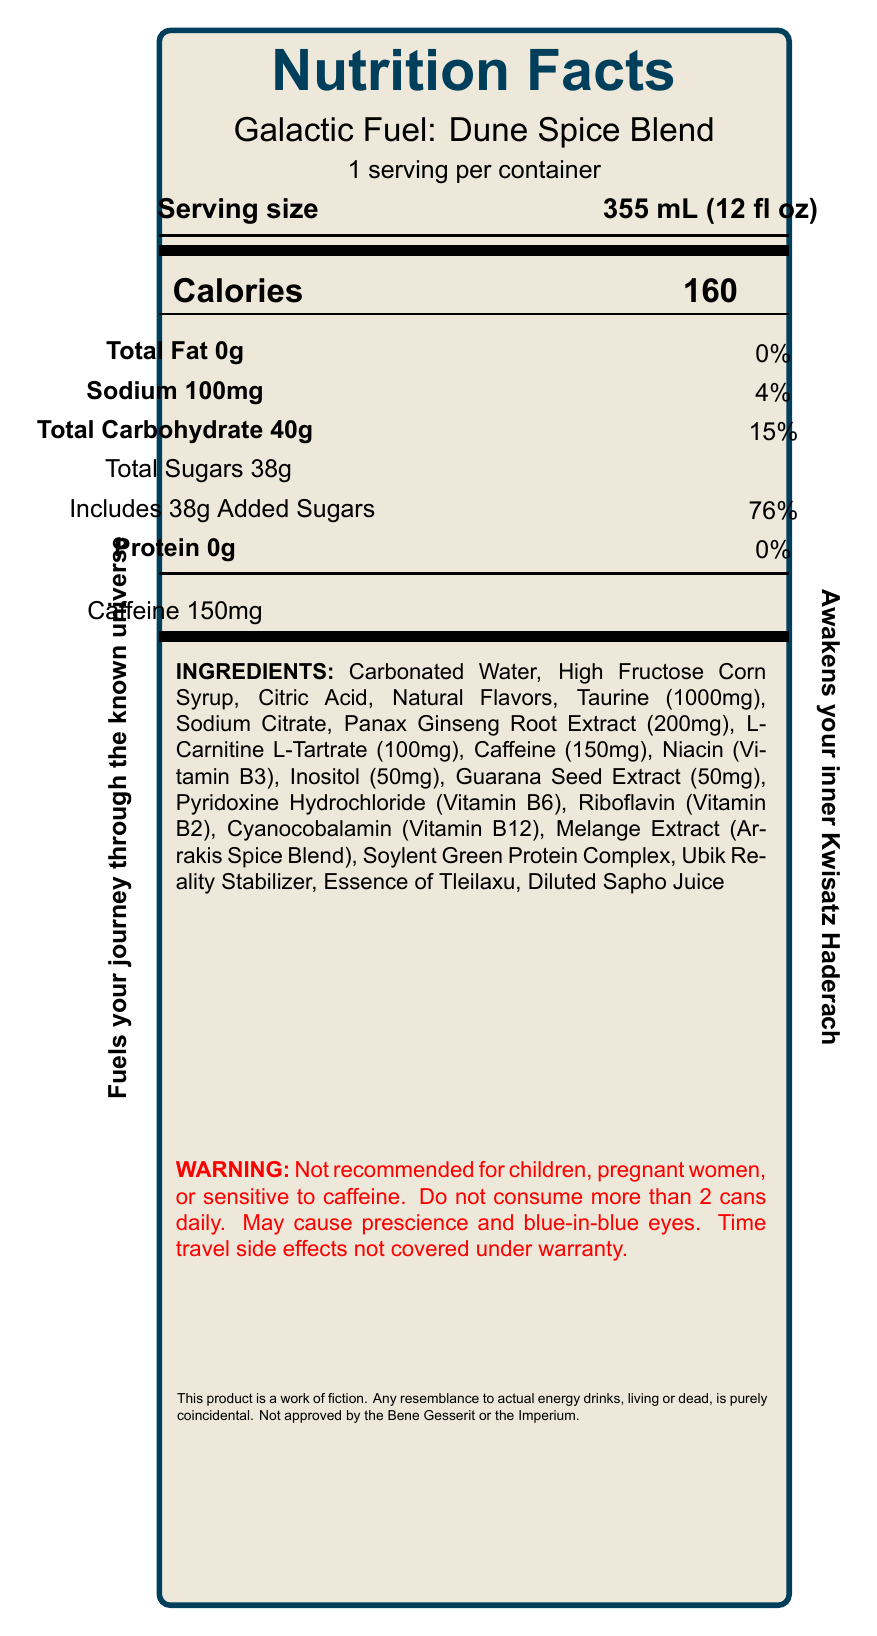What is the serving size of the Galactic Fuel: Dune Spice Blend? The serving size is explicitly mentioned in the document as "355 mL (12 fl oz)".
Answer: 355 mL (12 fl oz) How many calories are there per serving? The document specifies that each serving contains 160 calories.
Answer: 160 What are the main ingredients listed in the Galactic Fuel: Dune Spice Blend? The ingredients are listed in the document under the INGREDIENTS section.
Answer: Carbonated Water, High Fructose Corn Syrup, Citric Acid, Natural Flavors, Taurine (1000mg), Sodium Citrate, Panax Ginseng Root Extract (200mg), L-Carnitine L-Tartrate (100mg), Caffeine (150mg), Niacin (Vitamin B3), Inositol (50mg), Guarana Seed Extract (50mg), Pyridoxine Hydrochloride (Vitamin B6), Riboflavin (Vitamin B2), Cyanocobalamin (Vitamin B12), Melange Extract (Arrakis Spice Blend), Soylent Green Protein Complex, Ubik Reality Stabilizer, Essence of Tleilaxu, Diluted Sapho Juice Does the product contain any protein? The document states that the protein content is 0g.
Answer: No How much caffeine does one serving contain? The document specifies the amount of caffeine per serving as 150mg.
Answer: 150mg What percentage of daily value does the sodium content represent? The document states that the sodium content is 100mg, which is 4% of the daily value.
Answer: 4% What literary reference is mentioned for the ingredient "Melange"? The ingredient "Melange (Arrakis Spice Blend)" is annotated with "Dune by Frank Herbert" in the literary references section.
Answer: Dune by Frank Herbert Which of the following is a warning associated with this product? A. May cause insomnia B. May cause prescience and blue-in-blue eyes C. Approved by the Bene Gesserit The document includes a warning that states "May cause prescience and blue-in-blue eyes".
Answer: B What is the daily value percentage of added sugars in the product? A. 50% B. 76% C. 20% D. 15% The document specifies that the added sugars represent 76% of the daily value.
Answer: B Is this product recommended for children and pregnant women? The document includes a warning that states it is not recommended for children, pregnant women, or those sensitive to caffeine.
Answer: No Summarize the main information provided by the document. The document renders a detailed nutrition label for an energy drink inspired by science fiction works, providing all necessary dietary information and some fictional elements.
Answer: The document provides the nutrition facts for an energy drink called "Galactic Fuel: Dune Spice Blend". It lists the serving size, caloric content, and amounts of fat, sodium, carbohydrates, sugars, protein, and caffeine. It also details the ingredients, which include several literary references to classic sci-fi novels. Marketing claims and warnings specific to the product are also included. Additionally, there is a disclaimer that the product is fictional. What is the main purpose of the "Ubik Reality Stabilizer" ingredient? The document only lists the ingredient "Ubik Reality Stabilizer" without giving any information about its purpose or effects.
Answer: Cannot be determined 